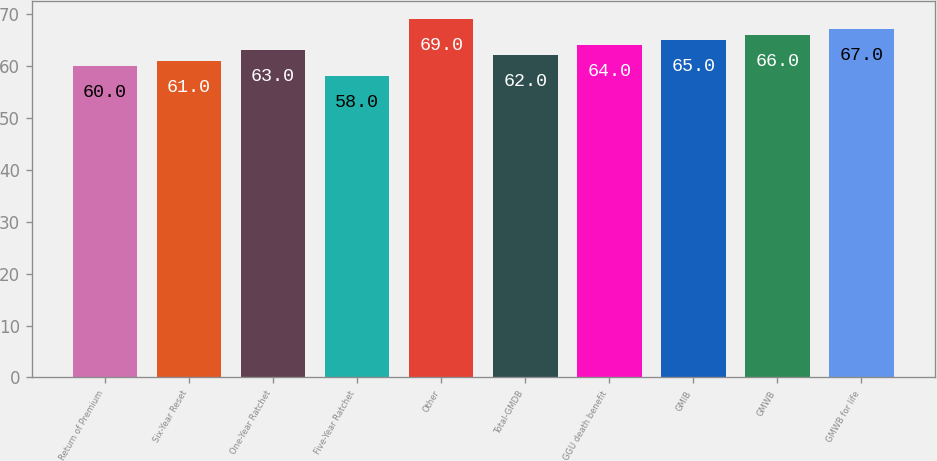<chart> <loc_0><loc_0><loc_500><loc_500><bar_chart><fcel>Return of Premium<fcel>Six-Year Reset<fcel>One-Year Ratchet<fcel>Five-Year Ratchet<fcel>Other<fcel>Total-GMDB<fcel>GGU death benefit<fcel>GMIB<fcel>GMWB<fcel>GMWB for life<nl><fcel>60<fcel>61<fcel>63<fcel>58<fcel>69<fcel>62<fcel>64<fcel>65<fcel>66<fcel>67<nl></chart> 